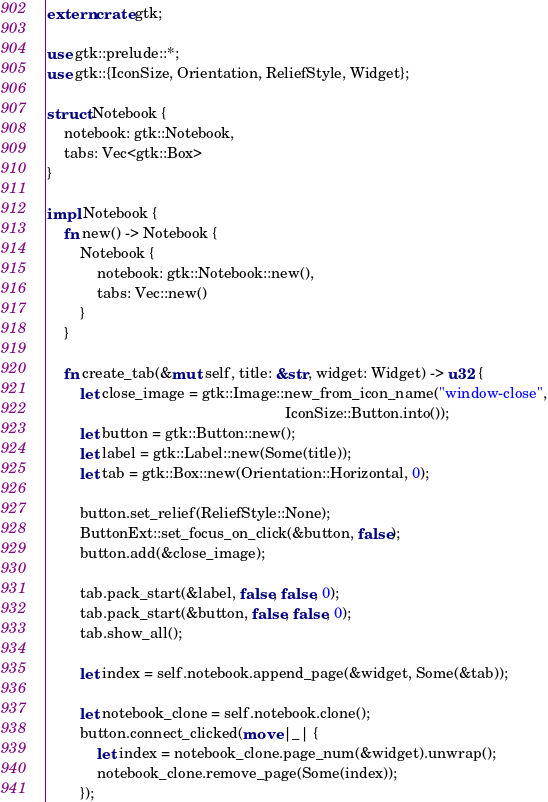Convert code to text. <code><loc_0><loc_0><loc_500><loc_500><_Rust_>extern crate gtk;

use gtk::prelude::*;
use gtk::{IconSize, Orientation, ReliefStyle, Widget};

struct Notebook {
    notebook: gtk::Notebook,
    tabs: Vec<gtk::Box>
}

impl Notebook {
    fn new() -> Notebook {
        Notebook {
            notebook: gtk::Notebook::new(),
            tabs: Vec::new()
        }
    }

    fn create_tab(&mut self, title: &str, widget: Widget) -> u32 {
        let close_image = gtk::Image::new_from_icon_name("window-close",
                                                         IconSize::Button.into());
        let button = gtk::Button::new();
        let label = gtk::Label::new(Some(title));
        let tab = gtk::Box::new(Orientation::Horizontal, 0);

        button.set_relief(ReliefStyle::None);
        ButtonExt::set_focus_on_click(&button, false);
        button.add(&close_image);

        tab.pack_start(&label, false, false, 0);
        tab.pack_start(&button, false, false, 0);
        tab.show_all();

        let index = self.notebook.append_page(&widget, Some(&tab));

        let notebook_clone = self.notebook.clone();
        button.connect_clicked(move |_| {
            let index = notebook_clone.page_num(&widget).unwrap();
            notebook_clone.remove_page(Some(index));
        });
</code> 